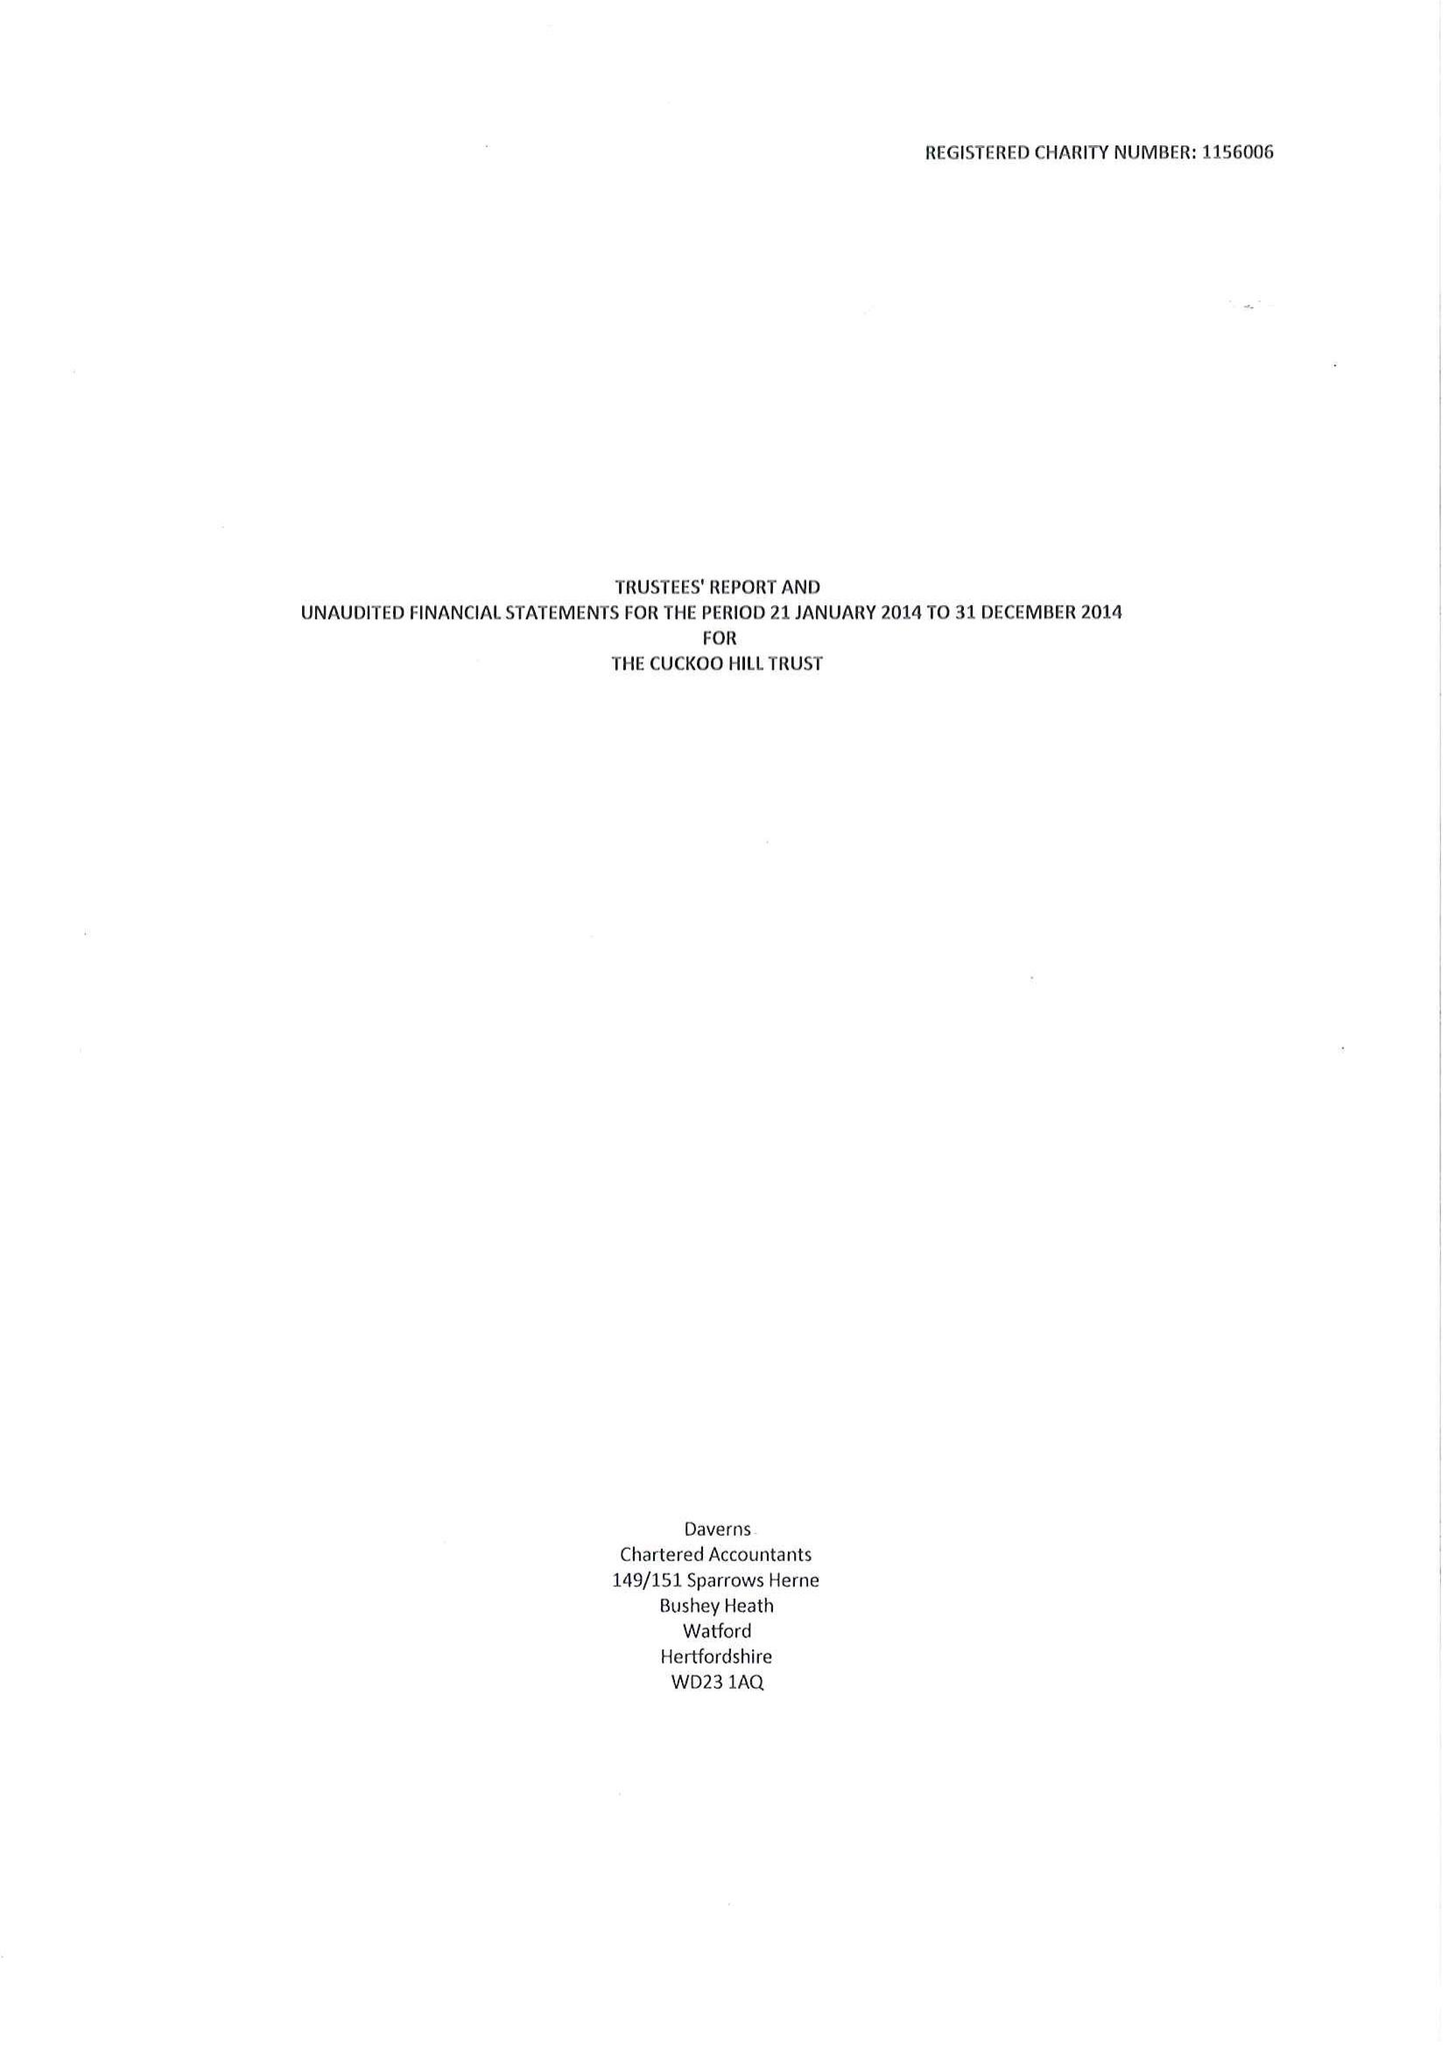What is the value for the address__postcode?
Answer the question using a single word or phrase. HA5 2BB 